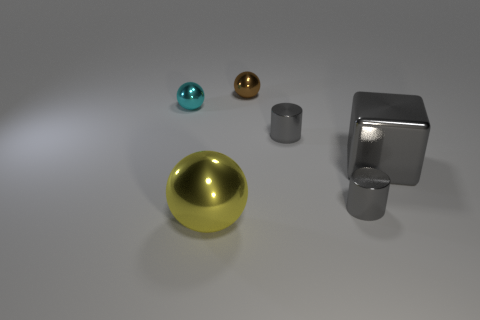Subtract all large balls. How many balls are left? 2 Add 3 gray shiny objects. How many objects exist? 9 Subtract all gray balls. Subtract all brown cubes. How many balls are left? 3 Subtract all small cyan rubber blocks. Subtract all big yellow metallic things. How many objects are left? 5 Add 2 small brown metallic objects. How many small brown metallic objects are left? 3 Add 3 red spheres. How many red spheres exist? 3 Subtract 1 gray cylinders. How many objects are left? 5 Subtract all cylinders. How many objects are left? 4 